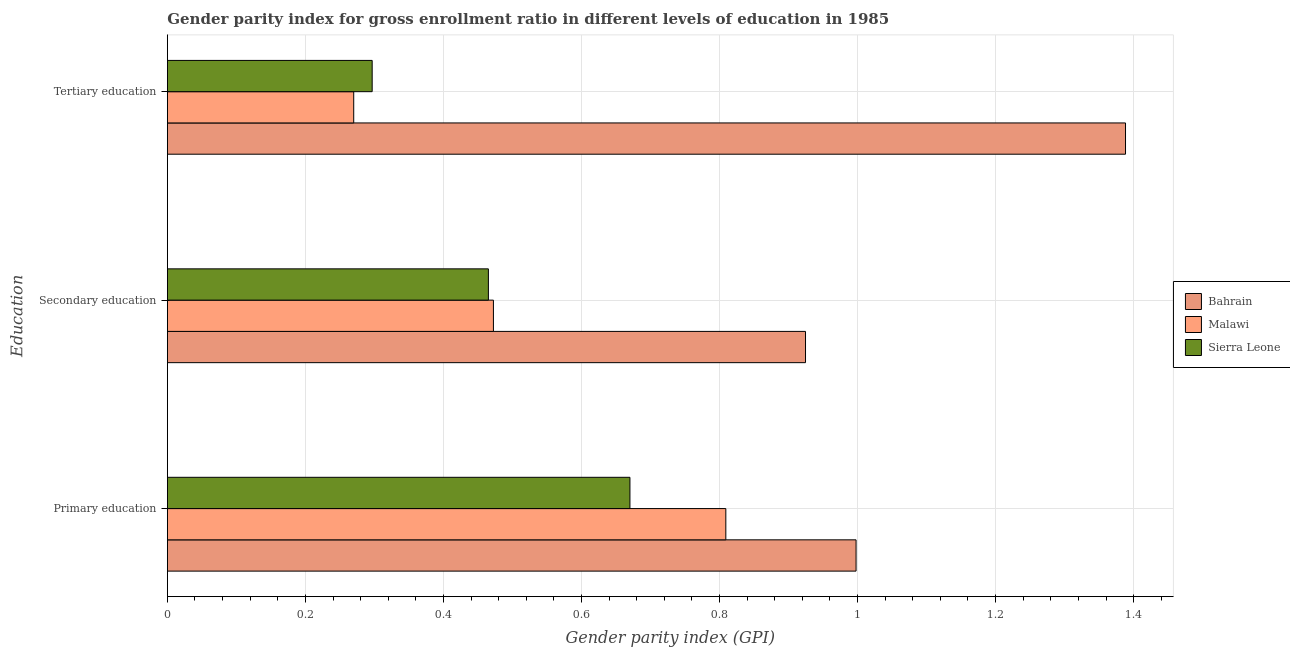Are the number of bars on each tick of the Y-axis equal?
Provide a succinct answer. Yes. How many bars are there on the 1st tick from the bottom?
Keep it short and to the point. 3. What is the label of the 1st group of bars from the top?
Provide a succinct answer. Tertiary education. What is the gender parity index in primary education in Sierra Leone?
Make the answer very short. 0.67. Across all countries, what is the maximum gender parity index in secondary education?
Provide a short and direct response. 0.92. Across all countries, what is the minimum gender parity index in tertiary education?
Provide a succinct answer. 0.27. In which country was the gender parity index in secondary education maximum?
Offer a terse response. Bahrain. In which country was the gender parity index in secondary education minimum?
Offer a terse response. Sierra Leone. What is the total gender parity index in primary education in the graph?
Offer a very short reply. 2.48. What is the difference between the gender parity index in tertiary education in Bahrain and that in Sierra Leone?
Keep it short and to the point. 1.09. What is the difference between the gender parity index in tertiary education in Sierra Leone and the gender parity index in primary education in Bahrain?
Offer a terse response. -0.7. What is the average gender parity index in tertiary education per country?
Your answer should be compact. 0.65. What is the difference between the gender parity index in primary education and gender parity index in tertiary education in Malawi?
Make the answer very short. 0.54. What is the ratio of the gender parity index in secondary education in Malawi to that in Sierra Leone?
Give a very brief answer. 1.02. Is the gender parity index in secondary education in Sierra Leone less than that in Malawi?
Provide a short and direct response. Yes. What is the difference between the highest and the second highest gender parity index in secondary education?
Make the answer very short. 0.45. What is the difference between the highest and the lowest gender parity index in secondary education?
Offer a very short reply. 0.46. In how many countries, is the gender parity index in secondary education greater than the average gender parity index in secondary education taken over all countries?
Your response must be concise. 1. Is the sum of the gender parity index in secondary education in Sierra Leone and Malawi greater than the maximum gender parity index in primary education across all countries?
Provide a succinct answer. No. What does the 2nd bar from the top in Tertiary education represents?
Your answer should be compact. Malawi. What does the 3rd bar from the bottom in Primary education represents?
Keep it short and to the point. Sierra Leone. Is it the case that in every country, the sum of the gender parity index in primary education and gender parity index in secondary education is greater than the gender parity index in tertiary education?
Provide a short and direct response. Yes. Are all the bars in the graph horizontal?
Provide a short and direct response. Yes. How many countries are there in the graph?
Your answer should be compact. 3. What is the difference between two consecutive major ticks on the X-axis?
Offer a very short reply. 0.2. Does the graph contain any zero values?
Give a very brief answer. No. What is the title of the graph?
Provide a succinct answer. Gender parity index for gross enrollment ratio in different levels of education in 1985. What is the label or title of the X-axis?
Ensure brevity in your answer.  Gender parity index (GPI). What is the label or title of the Y-axis?
Ensure brevity in your answer.  Education. What is the Gender parity index (GPI) in Bahrain in Primary education?
Offer a very short reply. 1. What is the Gender parity index (GPI) of Malawi in Primary education?
Provide a succinct answer. 0.81. What is the Gender parity index (GPI) in Sierra Leone in Primary education?
Keep it short and to the point. 0.67. What is the Gender parity index (GPI) in Bahrain in Secondary education?
Keep it short and to the point. 0.92. What is the Gender parity index (GPI) of Malawi in Secondary education?
Provide a succinct answer. 0.47. What is the Gender parity index (GPI) of Sierra Leone in Secondary education?
Offer a terse response. 0.47. What is the Gender parity index (GPI) of Bahrain in Tertiary education?
Offer a terse response. 1.39. What is the Gender parity index (GPI) of Malawi in Tertiary education?
Offer a terse response. 0.27. What is the Gender parity index (GPI) in Sierra Leone in Tertiary education?
Give a very brief answer. 0.3. Across all Education, what is the maximum Gender parity index (GPI) of Bahrain?
Keep it short and to the point. 1.39. Across all Education, what is the maximum Gender parity index (GPI) in Malawi?
Provide a succinct answer. 0.81. Across all Education, what is the maximum Gender parity index (GPI) of Sierra Leone?
Your answer should be compact. 0.67. Across all Education, what is the minimum Gender parity index (GPI) of Bahrain?
Ensure brevity in your answer.  0.92. Across all Education, what is the minimum Gender parity index (GPI) in Malawi?
Your response must be concise. 0.27. Across all Education, what is the minimum Gender parity index (GPI) in Sierra Leone?
Keep it short and to the point. 0.3. What is the total Gender parity index (GPI) of Bahrain in the graph?
Make the answer very short. 3.31. What is the total Gender parity index (GPI) in Malawi in the graph?
Your answer should be compact. 1.55. What is the total Gender parity index (GPI) in Sierra Leone in the graph?
Offer a terse response. 1.43. What is the difference between the Gender parity index (GPI) in Bahrain in Primary education and that in Secondary education?
Your answer should be very brief. 0.07. What is the difference between the Gender parity index (GPI) of Malawi in Primary education and that in Secondary education?
Your answer should be very brief. 0.34. What is the difference between the Gender parity index (GPI) of Sierra Leone in Primary education and that in Secondary education?
Provide a succinct answer. 0.21. What is the difference between the Gender parity index (GPI) of Bahrain in Primary education and that in Tertiary education?
Your answer should be compact. -0.39. What is the difference between the Gender parity index (GPI) of Malawi in Primary education and that in Tertiary education?
Offer a terse response. 0.54. What is the difference between the Gender parity index (GPI) of Sierra Leone in Primary education and that in Tertiary education?
Offer a terse response. 0.37. What is the difference between the Gender parity index (GPI) of Bahrain in Secondary education and that in Tertiary education?
Offer a terse response. -0.46. What is the difference between the Gender parity index (GPI) in Malawi in Secondary education and that in Tertiary education?
Provide a succinct answer. 0.2. What is the difference between the Gender parity index (GPI) in Sierra Leone in Secondary education and that in Tertiary education?
Your answer should be compact. 0.17. What is the difference between the Gender parity index (GPI) in Bahrain in Primary education and the Gender parity index (GPI) in Malawi in Secondary education?
Keep it short and to the point. 0.53. What is the difference between the Gender parity index (GPI) of Bahrain in Primary education and the Gender parity index (GPI) of Sierra Leone in Secondary education?
Your response must be concise. 0.53. What is the difference between the Gender parity index (GPI) of Malawi in Primary education and the Gender parity index (GPI) of Sierra Leone in Secondary education?
Your response must be concise. 0.34. What is the difference between the Gender parity index (GPI) of Bahrain in Primary education and the Gender parity index (GPI) of Malawi in Tertiary education?
Provide a short and direct response. 0.73. What is the difference between the Gender parity index (GPI) in Bahrain in Primary education and the Gender parity index (GPI) in Sierra Leone in Tertiary education?
Provide a succinct answer. 0.7. What is the difference between the Gender parity index (GPI) of Malawi in Primary education and the Gender parity index (GPI) of Sierra Leone in Tertiary education?
Provide a succinct answer. 0.51. What is the difference between the Gender parity index (GPI) of Bahrain in Secondary education and the Gender parity index (GPI) of Malawi in Tertiary education?
Your response must be concise. 0.65. What is the difference between the Gender parity index (GPI) of Bahrain in Secondary education and the Gender parity index (GPI) of Sierra Leone in Tertiary education?
Ensure brevity in your answer.  0.63. What is the difference between the Gender parity index (GPI) in Malawi in Secondary education and the Gender parity index (GPI) in Sierra Leone in Tertiary education?
Your answer should be compact. 0.18. What is the average Gender parity index (GPI) of Bahrain per Education?
Keep it short and to the point. 1.1. What is the average Gender parity index (GPI) in Malawi per Education?
Provide a succinct answer. 0.52. What is the average Gender parity index (GPI) of Sierra Leone per Education?
Ensure brevity in your answer.  0.48. What is the difference between the Gender parity index (GPI) in Bahrain and Gender parity index (GPI) in Malawi in Primary education?
Give a very brief answer. 0.19. What is the difference between the Gender parity index (GPI) in Bahrain and Gender parity index (GPI) in Sierra Leone in Primary education?
Make the answer very short. 0.33. What is the difference between the Gender parity index (GPI) of Malawi and Gender parity index (GPI) of Sierra Leone in Primary education?
Ensure brevity in your answer.  0.14. What is the difference between the Gender parity index (GPI) of Bahrain and Gender parity index (GPI) of Malawi in Secondary education?
Your answer should be compact. 0.45. What is the difference between the Gender parity index (GPI) of Bahrain and Gender parity index (GPI) of Sierra Leone in Secondary education?
Your answer should be very brief. 0.46. What is the difference between the Gender parity index (GPI) of Malawi and Gender parity index (GPI) of Sierra Leone in Secondary education?
Provide a succinct answer. 0.01. What is the difference between the Gender parity index (GPI) of Bahrain and Gender parity index (GPI) of Malawi in Tertiary education?
Your answer should be compact. 1.12. What is the difference between the Gender parity index (GPI) of Bahrain and Gender parity index (GPI) of Sierra Leone in Tertiary education?
Your answer should be compact. 1.09. What is the difference between the Gender parity index (GPI) of Malawi and Gender parity index (GPI) of Sierra Leone in Tertiary education?
Give a very brief answer. -0.03. What is the ratio of the Gender parity index (GPI) in Bahrain in Primary education to that in Secondary education?
Make the answer very short. 1.08. What is the ratio of the Gender parity index (GPI) in Malawi in Primary education to that in Secondary education?
Offer a terse response. 1.71. What is the ratio of the Gender parity index (GPI) of Sierra Leone in Primary education to that in Secondary education?
Provide a succinct answer. 1.44. What is the ratio of the Gender parity index (GPI) in Bahrain in Primary education to that in Tertiary education?
Your answer should be compact. 0.72. What is the ratio of the Gender parity index (GPI) of Malawi in Primary education to that in Tertiary education?
Make the answer very short. 3. What is the ratio of the Gender parity index (GPI) of Sierra Leone in Primary education to that in Tertiary education?
Make the answer very short. 2.26. What is the ratio of the Gender parity index (GPI) in Bahrain in Secondary education to that in Tertiary education?
Keep it short and to the point. 0.67. What is the ratio of the Gender parity index (GPI) of Malawi in Secondary education to that in Tertiary education?
Provide a succinct answer. 1.75. What is the ratio of the Gender parity index (GPI) of Sierra Leone in Secondary education to that in Tertiary education?
Offer a very short reply. 1.57. What is the difference between the highest and the second highest Gender parity index (GPI) in Bahrain?
Offer a very short reply. 0.39. What is the difference between the highest and the second highest Gender parity index (GPI) of Malawi?
Your answer should be compact. 0.34. What is the difference between the highest and the second highest Gender parity index (GPI) in Sierra Leone?
Keep it short and to the point. 0.21. What is the difference between the highest and the lowest Gender parity index (GPI) in Bahrain?
Offer a terse response. 0.46. What is the difference between the highest and the lowest Gender parity index (GPI) in Malawi?
Offer a terse response. 0.54. What is the difference between the highest and the lowest Gender parity index (GPI) in Sierra Leone?
Ensure brevity in your answer.  0.37. 